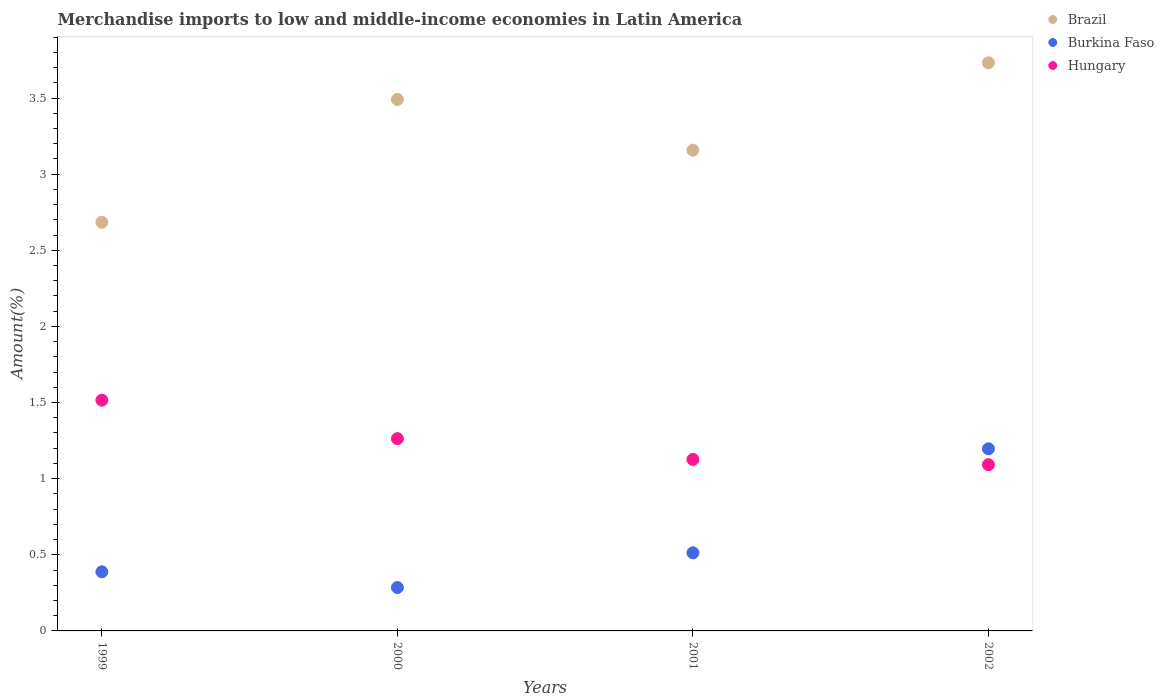How many different coloured dotlines are there?
Offer a terse response. 3. What is the percentage of amount earned from merchandise imports in Hungary in 2002?
Provide a succinct answer. 1.09. Across all years, what is the maximum percentage of amount earned from merchandise imports in Burkina Faso?
Your answer should be compact. 1.2. Across all years, what is the minimum percentage of amount earned from merchandise imports in Hungary?
Your answer should be compact. 1.09. In which year was the percentage of amount earned from merchandise imports in Brazil minimum?
Provide a succinct answer. 1999. What is the total percentage of amount earned from merchandise imports in Burkina Faso in the graph?
Make the answer very short. 2.38. What is the difference between the percentage of amount earned from merchandise imports in Hungary in 2000 and that in 2002?
Offer a terse response. 0.17. What is the difference between the percentage of amount earned from merchandise imports in Burkina Faso in 2002 and the percentage of amount earned from merchandise imports in Brazil in 1999?
Keep it short and to the point. -1.49. What is the average percentage of amount earned from merchandise imports in Brazil per year?
Make the answer very short. 3.27. In the year 1999, what is the difference between the percentage of amount earned from merchandise imports in Burkina Faso and percentage of amount earned from merchandise imports in Hungary?
Your response must be concise. -1.13. What is the ratio of the percentage of amount earned from merchandise imports in Brazil in 2000 to that in 2001?
Make the answer very short. 1.11. Is the difference between the percentage of amount earned from merchandise imports in Burkina Faso in 2000 and 2001 greater than the difference between the percentage of amount earned from merchandise imports in Hungary in 2000 and 2001?
Offer a very short reply. No. What is the difference between the highest and the second highest percentage of amount earned from merchandise imports in Brazil?
Keep it short and to the point. 0.24. What is the difference between the highest and the lowest percentage of amount earned from merchandise imports in Hungary?
Provide a short and direct response. 0.42. In how many years, is the percentage of amount earned from merchandise imports in Brazil greater than the average percentage of amount earned from merchandise imports in Brazil taken over all years?
Give a very brief answer. 2. Is it the case that in every year, the sum of the percentage of amount earned from merchandise imports in Hungary and percentage of amount earned from merchandise imports in Burkina Faso  is greater than the percentage of amount earned from merchandise imports in Brazil?
Your answer should be compact. No. Is the percentage of amount earned from merchandise imports in Brazil strictly less than the percentage of amount earned from merchandise imports in Burkina Faso over the years?
Your answer should be very brief. No. How many dotlines are there?
Offer a terse response. 3. Are the values on the major ticks of Y-axis written in scientific E-notation?
Your response must be concise. No. Does the graph contain grids?
Offer a very short reply. No. Where does the legend appear in the graph?
Give a very brief answer. Top right. How many legend labels are there?
Keep it short and to the point. 3. What is the title of the graph?
Your answer should be compact. Merchandise imports to low and middle-income economies in Latin America. What is the label or title of the X-axis?
Your answer should be very brief. Years. What is the label or title of the Y-axis?
Offer a very short reply. Amount(%). What is the Amount(%) of Brazil in 1999?
Keep it short and to the point. 2.68. What is the Amount(%) in Burkina Faso in 1999?
Ensure brevity in your answer.  0.39. What is the Amount(%) of Hungary in 1999?
Your answer should be compact. 1.52. What is the Amount(%) in Brazil in 2000?
Provide a short and direct response. 3.49. What is the Amount(%) in Burkina Faso in 2000?
Offer a terse response. 0.29. What is the Amount(%) in Hungary in 2000?
Provide a short and direct response. 1.26. What is the Amount(%) in Brazil in 2001?
Give a very brief answer. 3.16. What is the Amount(%) in Burkina Faso in 2001?
Your answer should be very brief. 0.51. What is the Amount(%) of Hungary in 2001?
Provide a succinct answer. 1.13. What is the Amount(%) of Brazil in 2002?
Give a very brief answer. 3.73. What is the Amount(%) in Burkina Faso in 2002?
Give a very brief answer. 1.2. What is the Amount(%) in Hungary in 2002?
Your response must be concise. 1.09. Across all years, what is the maximum Amount(%) in Brazil?
Keep it short and to the point. 3.73. Across all years, what is the maximum Amount(%) in Burkina Faso?
Offer a very short reply. 1.2. Across all years, what is the maximum Amount(%) of Hungary?
Your answer should be very brief. 1.52. Across all years, what is the minimum Amount(%) of Brazil?
Your answer should be very brief. 2.68. Across all years, what is the minimum Amount(%) in Burkina Faso?
Provide a short and direct response. 0.29. Across all years, what is the minimum Amount(%) of Hungary?
Your response must be concise. 1.09. What is the total Amount(%) in Brazil in the graph?
Provide a succinct answer. 13.06. What is the total Amount(%) of Burkina Faso in the graph?
Give a very brief answer. 2.38. What is the total Amount(%) of Hungary in the graph?
Make the answer very short. 5. What is the difference between the Amount(%) of Brazil in 1999 and that in 2000?
Provide a short and direct response. -0.81. What is the difference between the Amount(%) of Burkina Faso in 1999 and that in 2000?
Your answer should be very brief. 0.1. What is the difference between the Amount(%) in Hungary in 1999 and that in 2000?
Ensure brevity in your answer.  0.25. What is the difference between the Amount(%) in Brazil in 1999 and that in 2001?
Make the answer very short. -0.47. What is the difference between the Amount(%) in Burkina Faso in 1999 and that in 2001?
Your answer should be very brief. -0.12. What is the difference between the Amount(%) in Hungary in 1999 and that in 2001?
Offer a very short reply. 0.39. What is the difference between the Amount(%) in Brazil in 1999 and that in 2002?
Your response must be concise. -1.05. What is the difference between the Amount(%) of Burkina Faso in 1999 and that in 2002?
Your answer should be compact. -0.81. What is the difference between the Amount(%) in Hungary in 1999 and that in 2002?
Provide a short and direct response. 0.42. What is the difference between the Amount(%) of Brazil in 2000 and that in 2001?
Offer a terse response. 0.33. What is the difference between the Amount(%) in Burkina Faso in 2000 and that in 2001?
Give a very brief answer. -0.23. What is the difference between the Amount(%) of Hungary in 2000 and that in 2001?
Offer a very short reply. 0.14. What is the difference between the Amount(%) in Brazil in 2000 and that in 2002?
Your response must be concise. -0.24. What is the difference between the Amount(%) in Burkina Faso in 2000 and that in 2002?
Offer a terse response. -0.91. What is the difference between the Amount(%) in Hungary in 2000 and that in 2002?
Your response must be concise. 0.17. What is the difference between the Amount(%) of Brazil in 2001 and that in 2002?
Provide a succinct answer. -0.57. What is the difference between the Amount(%) in Burkina Faso in 2001 and that in 2002?
Make the answer very short. -0.68. What is the difference between the Amount(%) of Hungary in 2001 and that in 2002?
Your answer should be very brief. 0.03. What is the difference between the Amount(%) of Brazil in 1999 and the Amount(%) of Burkina Faso in 2000?
Provide a succinct answer. 2.4. What is the difference between the Amount(%) in Brazil in 1999 and the Amount(%) in Hungary in 2000?
Provide a short and direct response. 1.42. What is the difference between the Amount(%) in Burkina Faso in 1999 and the Amount(%) in Hungary in 2000?
Give a very brief answer. -0.87. What is the difference between the Amount(%) in Brazil in 1999 and the Amount(%) in Burkina Faso in 2001?
Make the answer very short. 2.17. What is the difference between the Amount(%) in Brazil in 1999 and the Amount(%) in Hungary in 2001?
Your answer should be very brief. 1.56. What is the difference between the Amount(%) in Burkina Faso in 1999 and the Amount(%) in Hungary in 2001?
Offer a very short reply. -0.74. What is the difference between the Amount(%) of Brazil in 1999 and the Amount(%) of Burkina Faso in 2002?
Keep it short and to the point. 1.49. What is the difference between the Amount(%) of Brazil in 1999 and the Amount(%) of Hungary in 2002?
Give a very brief answer. 1.59. What is the difference between the Amount(%) of Burkina Faso in 1999 and the Amount(%) of Hungary in 2002?
Provide a short and direct response. -0.7. What is the difference between the Amount(%) of Brazil in 2000 and the Amount(%) of Burkina Faso in 2001?
Your answer should be compact. 2.98. What is the difference between the Amount(%) in Brazil in 2000 and the Amount(%) in Hungary in 2001?
Ensure brevity in your answer.  2.36. What is the difference between the Amount(%) of Burkina Faso in 2000 and the Amount(%) of Hungary in 2001?
Your response must be concise. -0.84. What is the difference between the Amount(%) of Brazil in 2000 and the Amount(%) of Burkina Faso in 2002?
Provide a short and direct response. 2.29. What is the difference between the Amount(%) in Brazil in 2000 and the Amount(%) in Hungary in 2002?
Ensure brevity in your answer.  2.4. What is the difference between the Amount(%) in Burkina Faso in 2000 and the Amount(%) in Hungary in 2002?
Offer a very short reply. -0.81. What is the difference between the Amount(%) in Brazil in 2001 and the Amount(%) in Burkina Faso in 2002?
Provide a succinct answer. 1.96. What is the difference between the Amount(%) in Brazil in 2001 and the Amount(%) in Hungary in 2002?
Your answer should be very brief. 2.07. What is the difference between the Amount(%) in Burkina Faso in 2001 and the Amount(%) in Hungary in 2002?
Give a very brief answer. -0.58. What is the average Amount(%) in Brazil per year?
Ensure brevity in your answer.  3.27. What is the average Amount(%) in Burkina Faso per year?
Ensure brevity in your answer.  0.6. What is the average Amount(%) in Hungary per year?
Make the answer very short. 1.25. In the year 1999, what is the difference between the Amount(%) of Brazil and Amount(%) of Burkina Faso?
Provide a succinct answer. 2.3. In the year 1999, what is the difference between the Amount(%) in Brazil and Amount(%) in Hungary?
Ensure brevity in your answer.  1.17. In the year 1999, what is the difference between the Amount(%) in Burkina Faso and Amount(%) in Hungary?
Ensure brevity in your answer.  -1.13. In the year 2000, what is the difference between the Amount(%) in Brazil and Amount(%) in Burkina Faso?
Make the answer very short. 3.21. In the year 2000, what is the difference between the Amount(%) of Brazil and Amount(%) of Hungary?
Provide a short and direct response. 2.23. In the year 2000, what is the difference between the Amount(%) of Burkina Faso and Amount(%) of Hungary?
Ensure brevity in your answer.  -0.98. In the year 2001, what is the difference between the Amount(%) in Brazil and Amount(%) in Burkina Faso?
Provide a succinct answer. 2.64. In the year 2001, what is the difference between the Amount(%) in Brazil and Amount(%) in Hungary?
Provide a succinct answer. 2.03. In the year 2001, what is the difference between the Amount(%) in Burkina Faso and Amount(%) in Hungary?
Provide a short and direct response. -0.61. In the year 2002, what is the difference between the Amount(%) of Brazil and Amount(%) of Burkina Faso?
Offer a very short reply. 2.54. In the year 2002, what is the difference between the Amount(%) of Brazil and Amount(%) of Hungary?
Make the answer very short. 2.64. In the year 2002, what is the difference between the Amount(%) in Burkina Faso and Amount(%) in Hungary?
Give a very brief answer. 0.1. What is the ratio of the Amount(%) of Brazil in 1999 to that in 2000?
Keep it short and to the point. 0.77. What is the ratio of the Amount(%) in Burkina Faso in 1999 to that in 2000?
Provide a short and direct response. 1.36. What is the ratio of the Amount(%) of Hungary in 1999 to that in 2000?
Make the answer very short. 1.2. What is the ratio of the Amount(%) of Brazil in 1999 to that in 2001?
Keep it short and to the point. 0.85. What is the ratio of the Amount(%) in Burkina Faso in 1999 to that in 2001?
Offer a terse response. 0.76. What is the ratio of the Amount(%) of Hungary in 1999 to that in 2001?
Your answer should be compact. 1.35. What is the ratio of the Amount(%) of Brazil in 1999 to that in 2002?
Your answer should be very brief. 0.72. What is the ratio of the Amount(%) of Burkina Faso in 1999 to that in 2002?
Provide a short and direct response. 0.32. What is the ratio of the Amount(%) of Hungary in 1999 to that in 2002?
Your answer should be very brief. 1.39. What is the ratio of the Amount(%) in Brazil in 2000 to that in 2001?
Keep it short and to the point. 1.11. What is the ratio of the Amount(%) of Burkina Faso in 2000 to that in 2001?
Ensure brevity in your answer.  0.56. What is the ratio of the Amount(%) in Hungary in 2000 to that in 2001?
Your response must be concise. 1.12. What is the ratio of the Amount(%) in Brazil in 2000 to that in 2002?
Provide a short and direct response. 0.94. What is the ratio of the Amount(%) of Burkina Faso in 2000 to that in 2002?
Make the answer very short. 0.24. What is the ratio of the Amount(%) in Hungary in 2000 to that in 2002?
Offer a terse response. 1.16. What is the ratio of the Amount(%) in Brazil in 2001 to that in 2002?
Keep it short and to the point. 0.85. What is the ratio of the Amount(%) of Burkina Faso in 2001 to that in 2002?
Your answer should be very brief. 0.43. What is the ratio of the Amount(%) of Hungary in 2001 to that in 2002?
Provide a succinct answer. 1.03. What is the difference between the highest and the second highest Amount(%) of Brazil?
Your answer should be very brief. 0.24. What is the difference between the highest and the second highest Amount(%) of Burkina Faso?
Give a very brief answer. 0.68. What is the difference between the highest and the second highest Amount(%) of Hungary?
Your answer should be very brief. 0.25. What is the difference between the highest and the lowest Amount(%) of Brazil?
Make the answer very short. 1.05. What is the difference between the highest and the lowest Amount(%) of Burkina Faso?
Provide a short and direct response. 0.91. What is the difference between the highest and the lowest Amount(%) of Hungary?
Give a very brief answer. 0.42. 